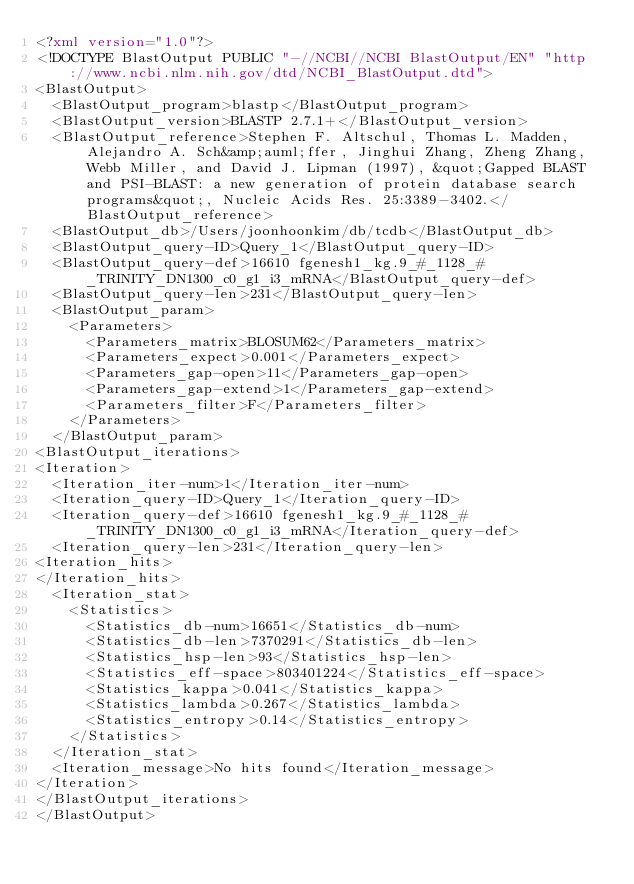Convert code to text. <code><loc_0><loc_0><loc_500><loc_500><_XML_><?xml version="1.0"?>
<!DOCTYPE BlastOutput PUBLIC "-//NCBI//NCBI BlastOutput/EN" "http://www.ncbi.nlm.nih.gov/dtd/NCBI_BlastOutput.dtd">
<BlastOutput>
  <BlastOutput_program>blastp</BlastOutput_program>
  <BlastOutput_version>BLASTP 2.7.1+</BlastOutput_version>
  <BlastOutput_reference>Stephen F. Altschul, Thomas L. Madden, Alejandro A. Sch&amp;auml;ffer, Jinghui Zhang, Zheng Zhang, Webb Miller, and David J. Lipman (1997), &quot;Gapped BLAST and PSI-BLAST: a new generation of protein database search programs&quot;, Nucleic Acids Res. 25:3389-3402.</BlastOutput_reference>
  <BlastOutput_db>/Users/joonhoonkim/db/tcdb</BlastOutput_db>
  <BlastOutput_query-ID>Query_1</BlastOutput_query-ID>
  <BlastOutput_query-def>16610 fgenesh1_kg.9_#_1128_#_TRINITY_DN1300_c0_g1_i3_mRNA</BlastOutput_query-def>
  <BlastOutput_query-len>231</BlastOutput_query-len>
  <BlastOutput_param>
    <Parameters>
      <Parameters_matrix>BLOSUM62</Parameters_matrix>
      <Parameters_expect>0.001</Parameters_expect>
      <Parameters_gap-open>11</Parameters_gap-open>
      <Parameters_gap-extend>1</Parameters_gap-extend>
      <Parameters_filter>F</Parameters_filter>
    </Parameters>
  </BlastOutput_param>
<BlastOutput_iterations>
<Iteration>
  <Iteration_iter-num>1</Iteration_iter-num>
  <Iteration_query-ID>Query_1</Iteration_query-ID>
  <Iteration_query-def>16610 fgenesh1_kg.9_#_1128_#_TRINITY_DN1300_c0_g1_i3_mRNA</Iteration_query-def>
  <Iteration_query-len>231</Iteration_query-len>
<Iteration_hits>
</Iteration_hits>
  <Iteration_stat>
    <Statistics>
      <Statistics_db-num>16651</Statistics_db-num>
      <Statistics_db-len>7370291</Statistics_db-len>
      <Statistics_hsp-len>93</Statistics_hsp-len>
      <Statistics_eff-space>803401224</Statistics_eff-space>
      <Statistics_kappa>0.041</Statistics_kappa>
      <Statistics_lambda>0.267</Statistics_lambda>
      <Statistics_entropy>0.14</Statistics_entropy>
    </Statistics>
  </Iteration_stat>
  <Iteration_message>No hits found</Iteration_message>
</Iteration>
</BlastOutput_iterations>
</BlastOutput>

</code> 